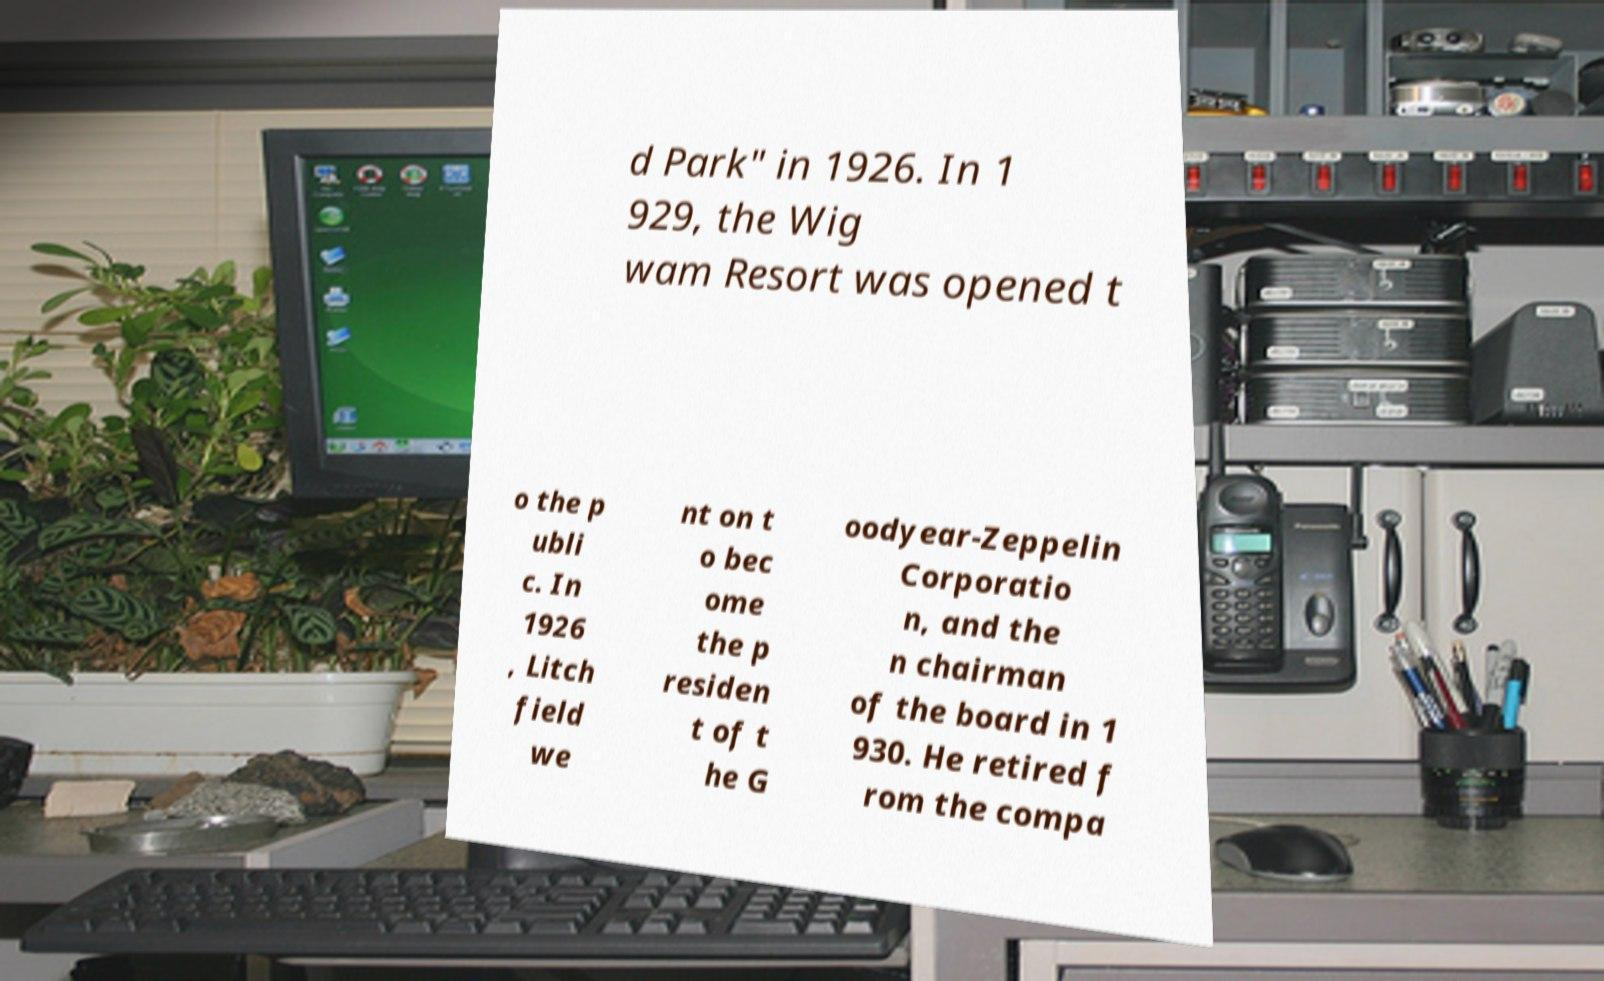Could you extract and type out the text from this image? d Park" in 1926. In 1 929, the Wig wam Resort was opened t o the p ubli c. In 1926 , Litch field we nt on t o bec ome the p residen t of t he G oodyear-Zeppelin Corporatio n, and the n chairman of the board in 1 930. He retired f rom the compa 